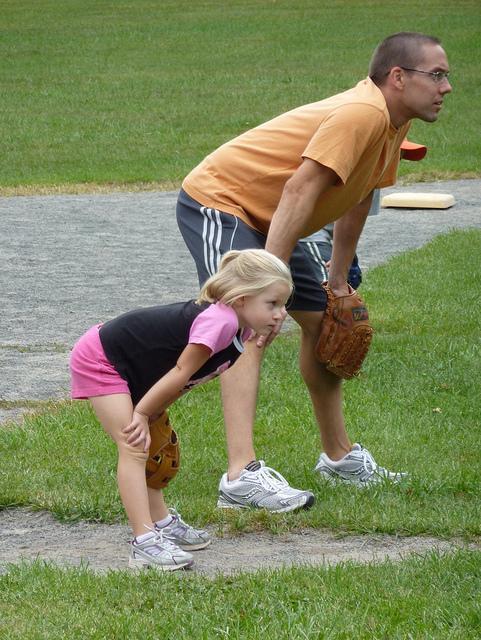How many people are visible?
Give a very brief answer. 2. How many black railroad cars are at the train station?
Give a very brief answer. 0. 